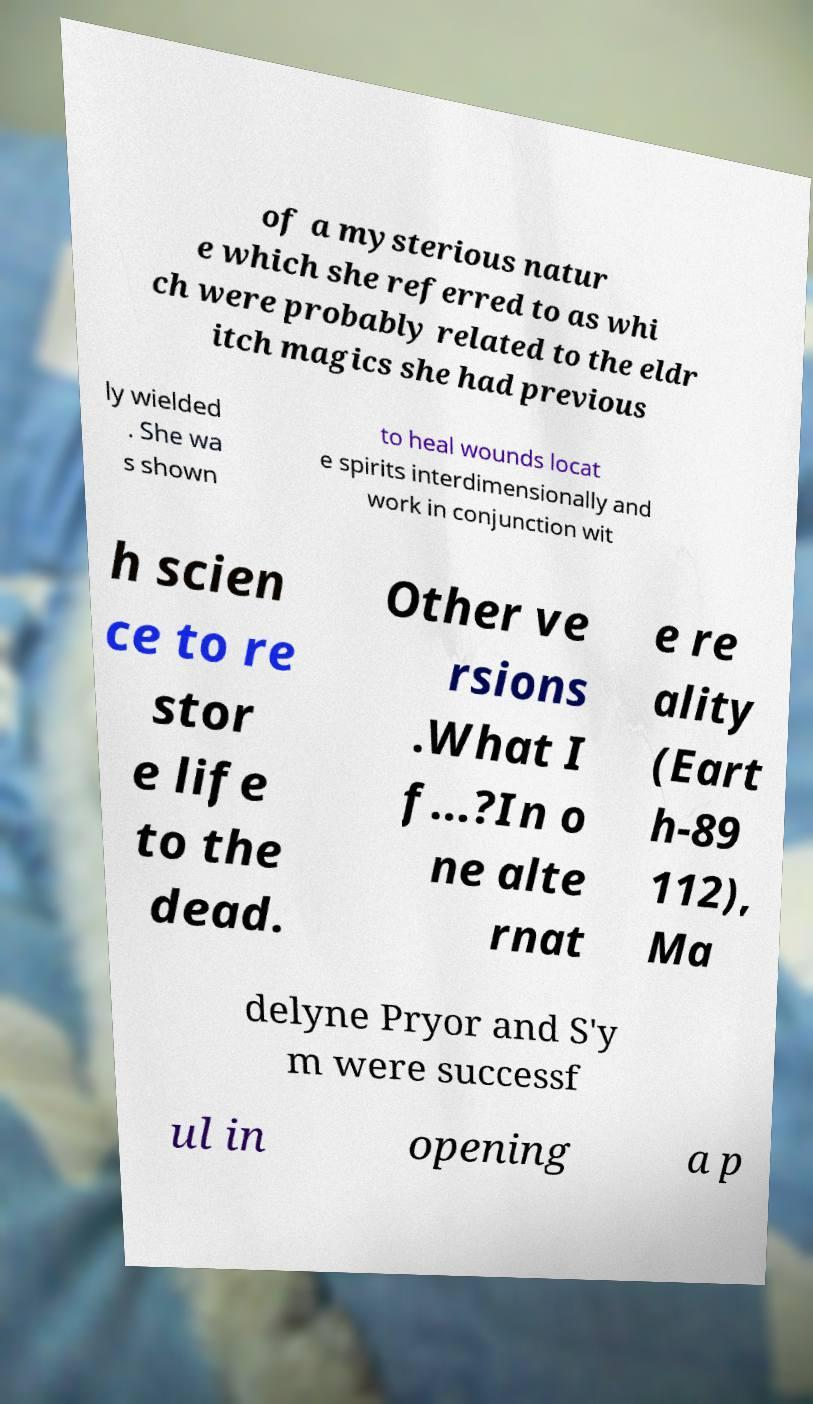Could you extract and type out the text from this image? of a mysterious natur e which she referred to as whi ch were probably related to the eldr itch magics she had previous ly wielded . She wa s shown to heal wounds locat e spirits interdimensionally and work in conjunction wit h scien ce to re stor e life to the dead. Other ve rsions .What I f...?In o ne alte rnat e re ality (Eart h-89 112), Ma delyne Pryor and S'y m were successf ul in opening a p 